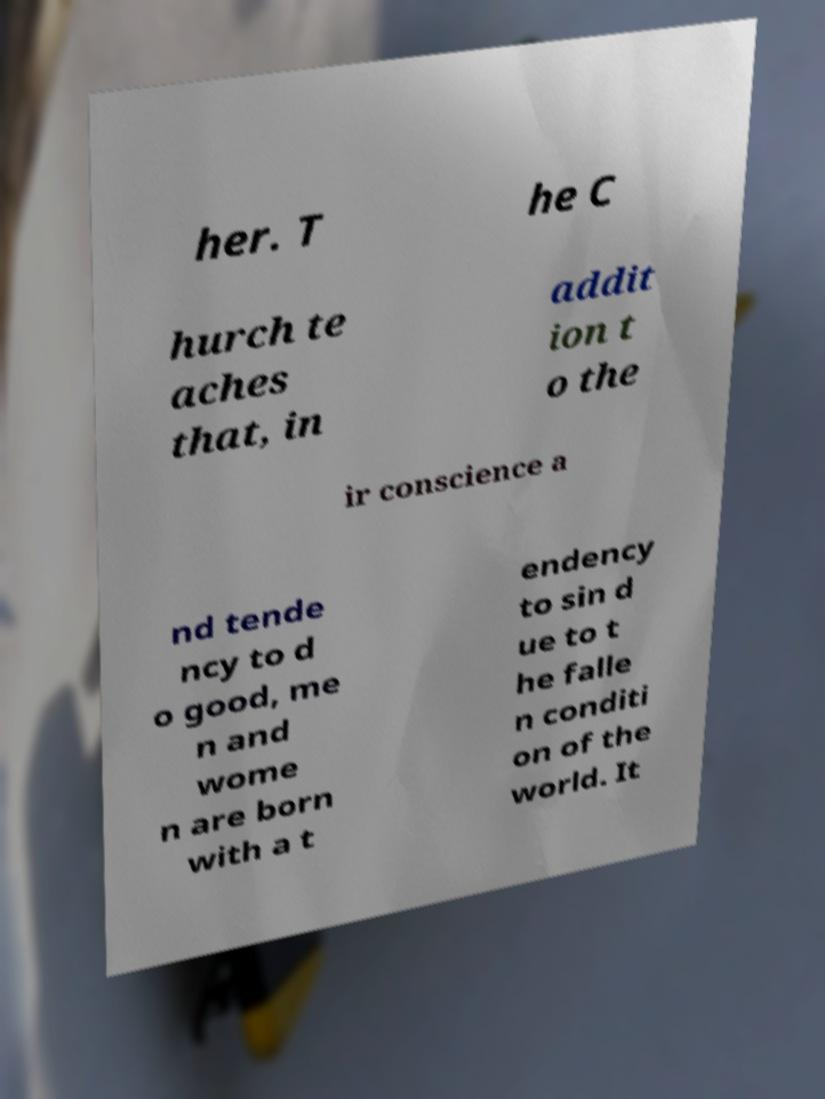Can you accurately transcribe the text from the provided image for me? her. T he C hurch te aches that, in addit ion t o the ir conscience a nd tende ncy to d o good, me n and wome n are born with a t endency to sin d ue to t he falle n conditi on of the world. It 